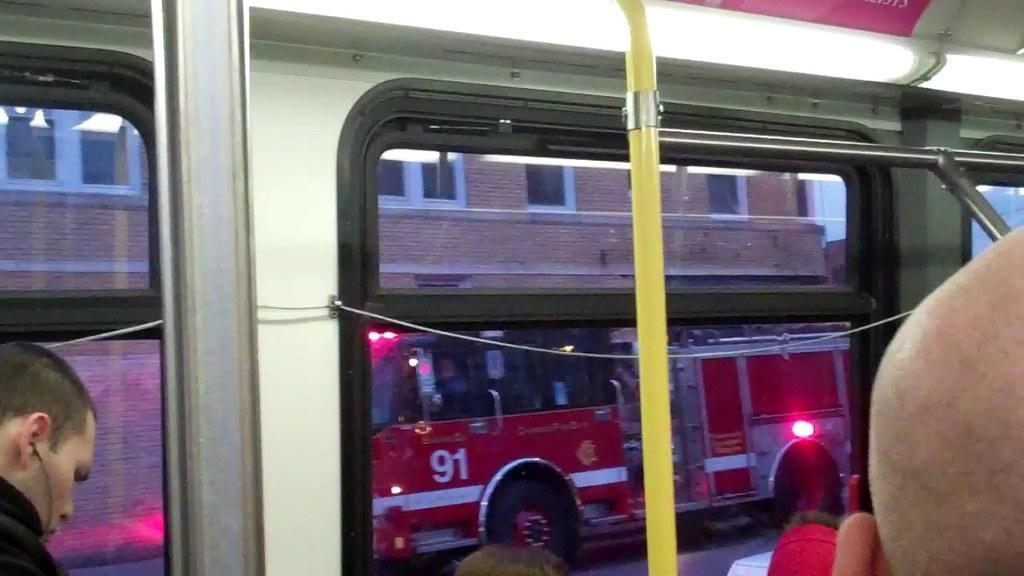Can you describe this image briefly? In this picture we can see vehicles on the road with some persons inside it and in the background we can see a building with windows. 